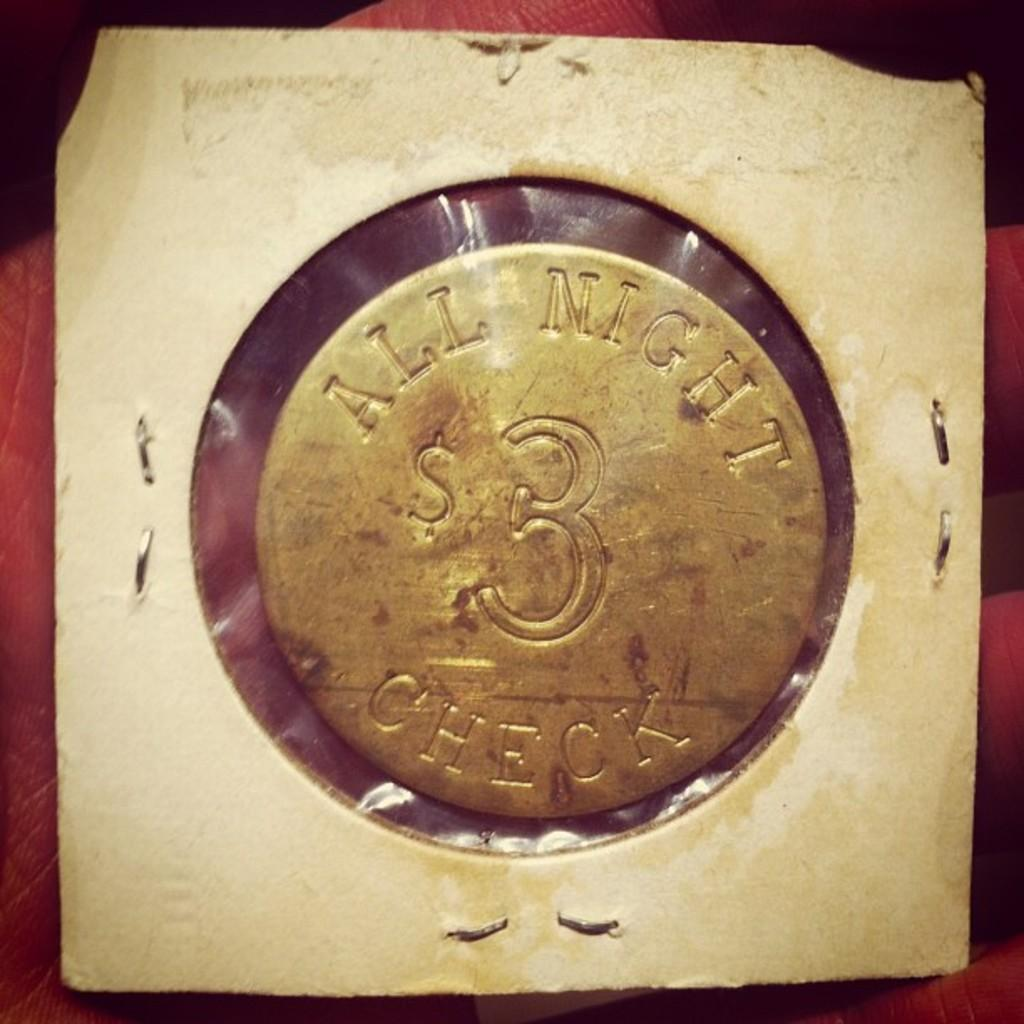<image>
Relay a brief, clear account of the picture shown. A gold coin that is in packaging that has " All night checks" written on it. 